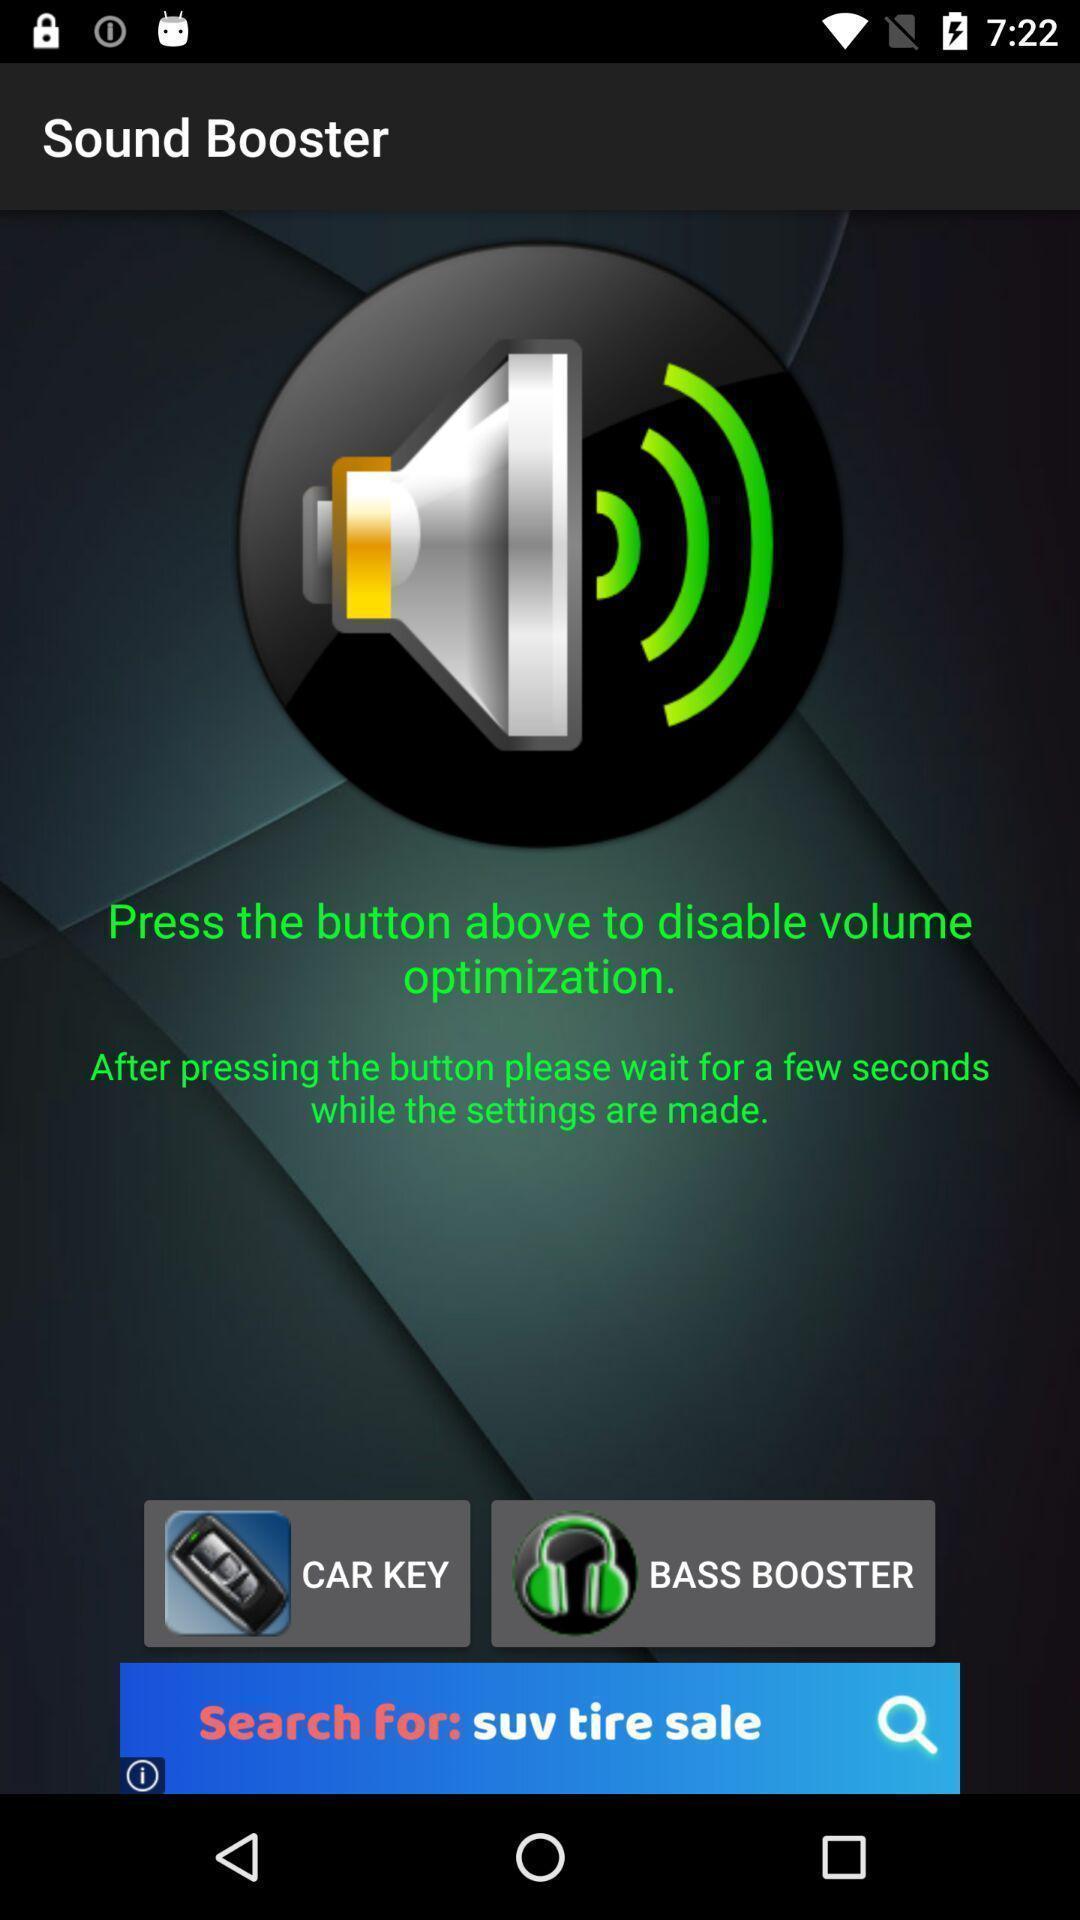Summarize the main components in this picture. Page to adjust the volume. 